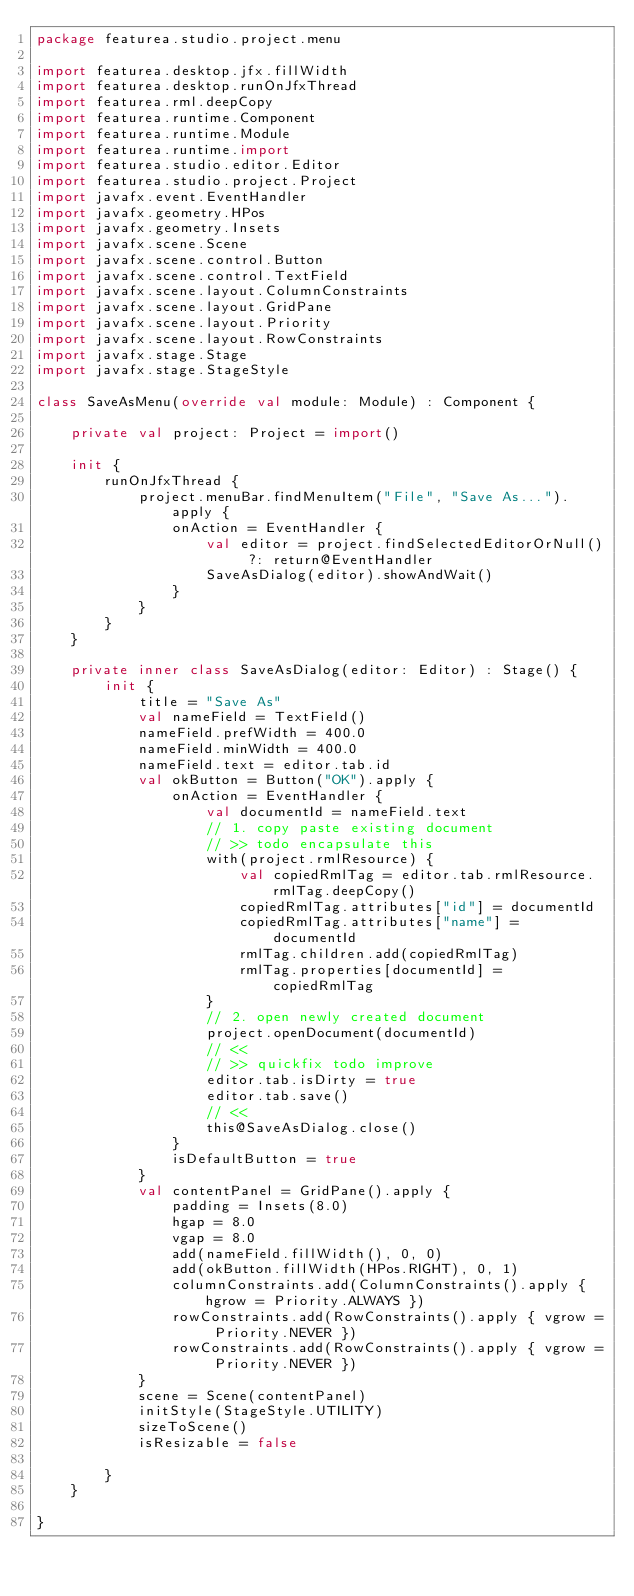Convert code to text. <code><loc_0><loc_0><loc_500><loc_500><_Kotlin_>package featurea.studio.project.menu

import featurea.desktop.jfx.fillWidth
import featurea.desktop.runOnJfxThread
import featurea.rml.deepCopy
import featurea.runtime.Component
import featurea.runtime.Module
import featurea.runtime.import
import featurea.studio.editor.Editor
import featurea.studio.project.Project
import javafx.event.EventHandler
import javafx.geometry.HPos
import javafx.geometry.Insets
import javafx.scene.Scene
import javafx.scene.control.Button
import javafx.scene.control.TextField
import javafx.scene.layout.ColumnConstraints
import javafx.scene.layout.GridPane
import javafx.scene.layout.Priority
import javafx.scene.layout.RowConstraints
import javafx.stage.Stage
import javafx.stage.StageStyle

class SaveAsMenu(override val module: Module) : Component {

    private val project: Project = import()

    init {
        runOnJfxThread {
            project.menuBar.findMenuItem("File", "Save As...").apply {
                onAction = EventHandler {
                    val editor = project.findSelectedEditorOrNull() ?: return@EventHandler
                    SaveAsDialog(editor).showAndWait()
                }
            }
        }
    }

    private inner class SaveAsDialog(editor: Editor) : Stage() {
        init {
            title = "Save As"
            val nameField = TextField()
            nameField.prefWidth = 400.0
            nameField.minWidth = 400.0
            nameField.text = editor.tab.id
            val okButton = Button("OK").apply {
                onAction = EventHandler {
                    val documentId = nameField.text
                    // 1. copy paste existing document
                    // >> todo encapsulate this
                    with(project.rmlResource) {
                        val copiedRmlTag = editor.tab.rmlResource.rmlTag.deepCopy()
                        copiedRmlTag.attributes["id"] = documentId
                        copiedRmlTag.attributes["name"] = documentId
                        rmlTag.children.add(copiedRmlTag)
                        rmlTag.properties[documentId] = copiedRmlTag
                    }
                    // 2. open newly created document
                    project.openDocument(documentId)
                    // <<
                    // >> quickfix todo improve
                    editor.tab.isDirty = true
                    editor.tab.save()
                    // <<
                    this@SaveAsDialog.close()
                }
                isDefaultButton = true
            }
            val contentPanel = GridPane().apply {
                padding = Insets(8.0)
                hgap = 8.0
                vgap = 8.0
                add(nameField.fillWidth(), 0, 0)
                add(okButton.fillWidth(HPos.RIGHT), 0, 1)
                columnConstraints.add(ColumnConstraints().apply { hgrow = Priority.ALWAYS })
                rowConstraints.add(RowConstraints().apply { vgrow = Priority.NEVER })
                rowConstraints.add(RowConstraints().apply { vgrow = Priority.NEVER })
            }
            scene = Scene(contentPanel)
            initStyle(StageStyle.UTILITY)
            sizeToScene()
            isResizable = false

        }
    }

}

</code> 